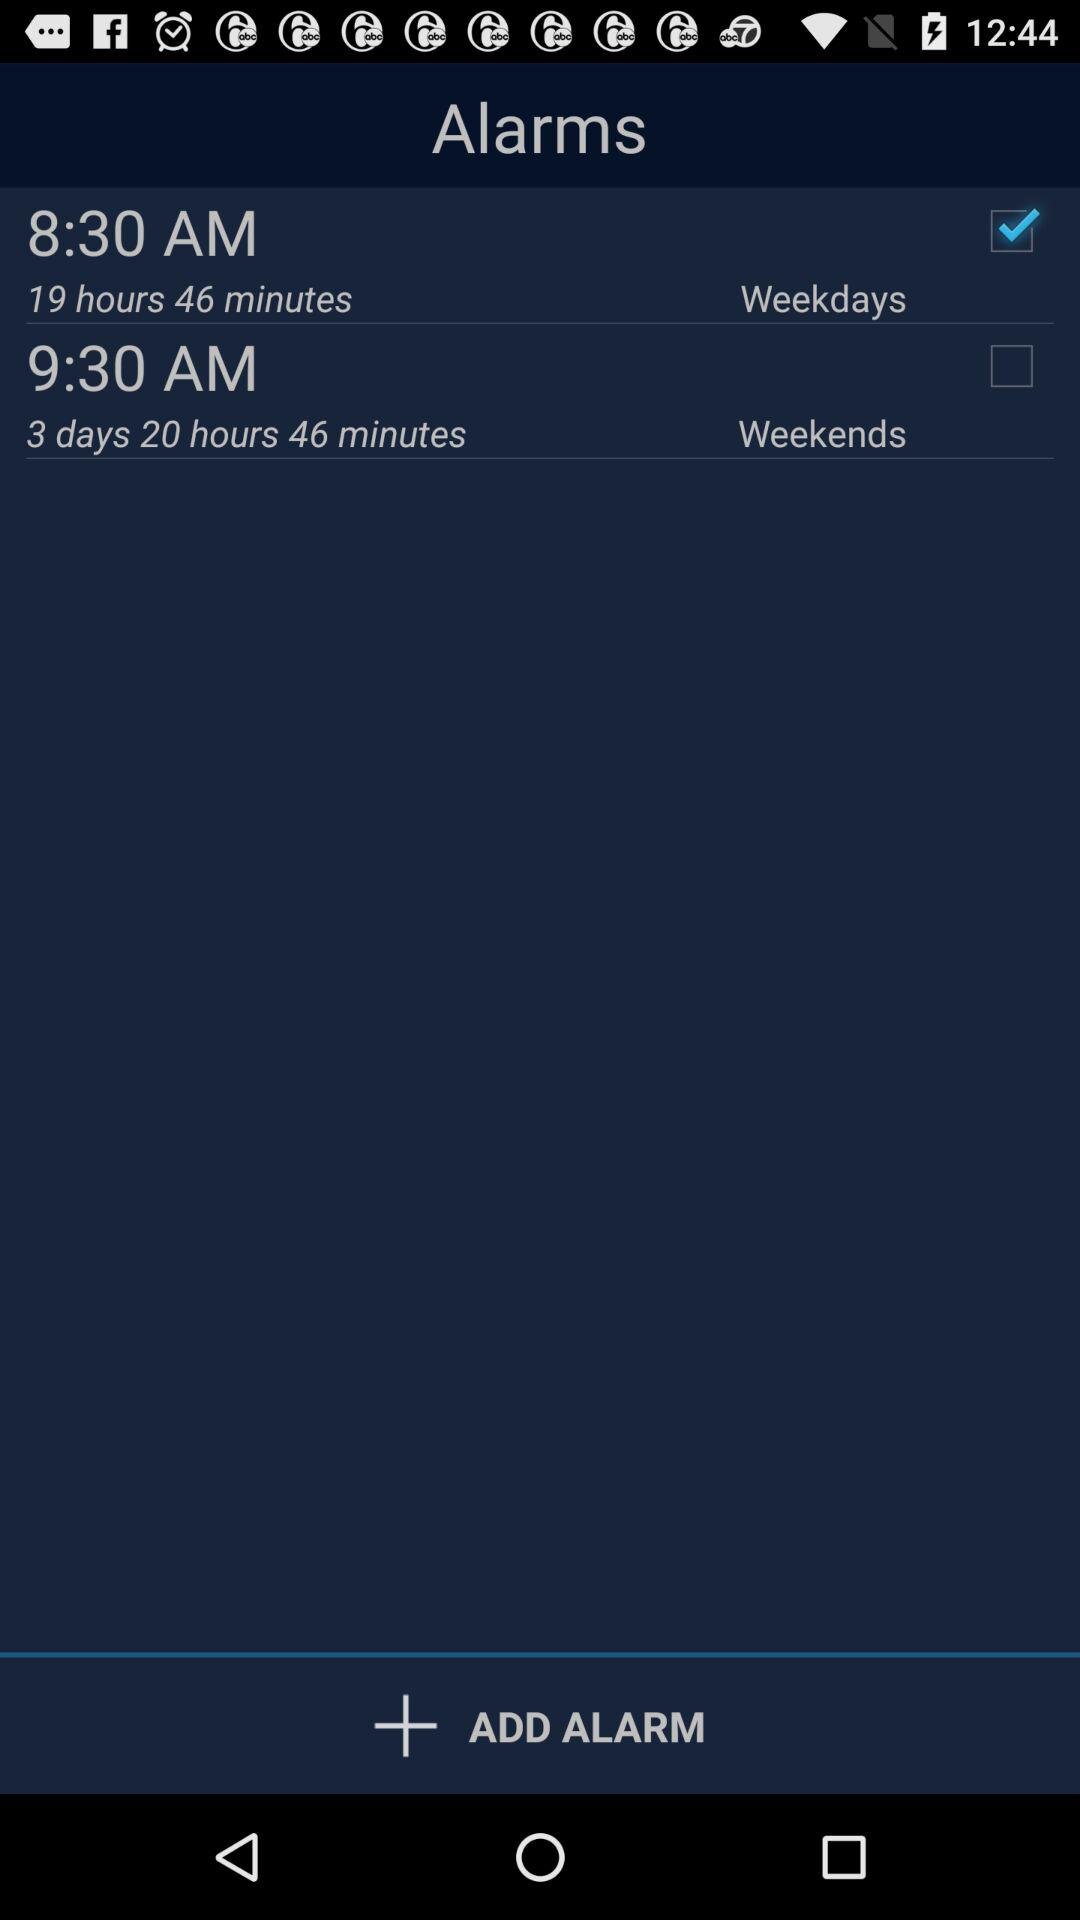What is the status of 9:30 AM? The status is off. 